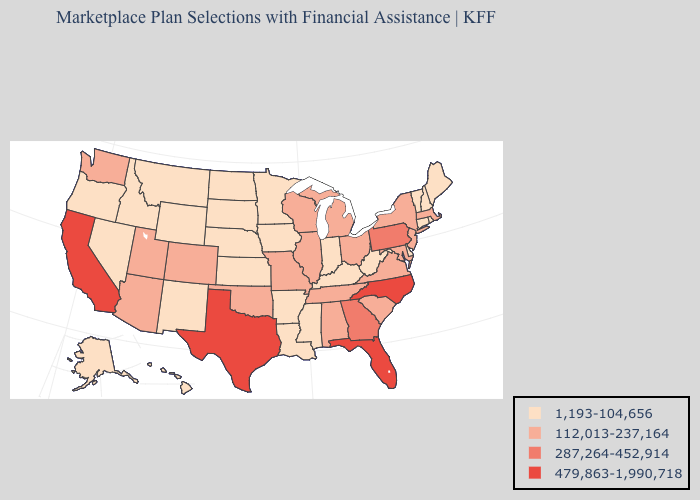Does California have a lower value than Ohio?
Write a very short answer. No. Name the states that have a value in the range 479,863-1,990,718?
Short answer required. California, Florida, North Carolina, Texas. How many symbols are there in the legend?
Concise answer only. 4. Name the states that have a value in the range 287,264-452,914?
Give a very brief answer. Georgia, Pennsylvania. Among the states that border Virginia , does Tennessee have the highest value?
Short answer required. No. Which states hav the highest value in the West?
Short answer required. California. Which states hav the highest value in the South?
Short answer required. Florida, North Carolina, Texas. Name the states that have a value in the range 112,013-237,164?
Keep it brief. Alabama, Arizona, Colorado, Illinois, Maryland, Massachusetts, Michigan, Missouri, New Jersey, New York, Ohio, Oklahoma, South Carolina, Tennessee, Utah, Virginia, Washington, Wisconsin. Which states have the lowest value in the West?
Give a very brief answer. Alaska, Hawaii, Idaho, Montana, Nevada, New Mexico, Oregon, Wyoming. What is the highest value in states that border Arkansas?
Write a very short answer. 479,863-1,990,718. Name the states that have a value in the range 287,264-452,914?
Answer briefly. Georgia, Pennsylvania. What is the value of New York?
Give a very brief answer. 112,013-237,164. Which states hav the highest value in the Northeast?
Give a very brief answer. Pennsylvania. Which states have the lowest value in the MidWest?
Quick response, please. Indiana, Iowa, Kansas, Minnesota, Nebraska, North Dakota, South Dakota. Name the states that have a value in the range 1,193-104,656?
Short answer required. Alaska, Arkansas, Connecticut, Delaware, Hawaii, Idaho, Indiana, Iowa, Kansas, Kentucky, Louisiana, Maine, Minnesota, Mississippi, Montana, Nebraska, Nevada, New Hampshire, New Mexico, North Dakota, Oregon, Rhode Island, South Dakota, Vermont, West Virginia, Wyoming. 